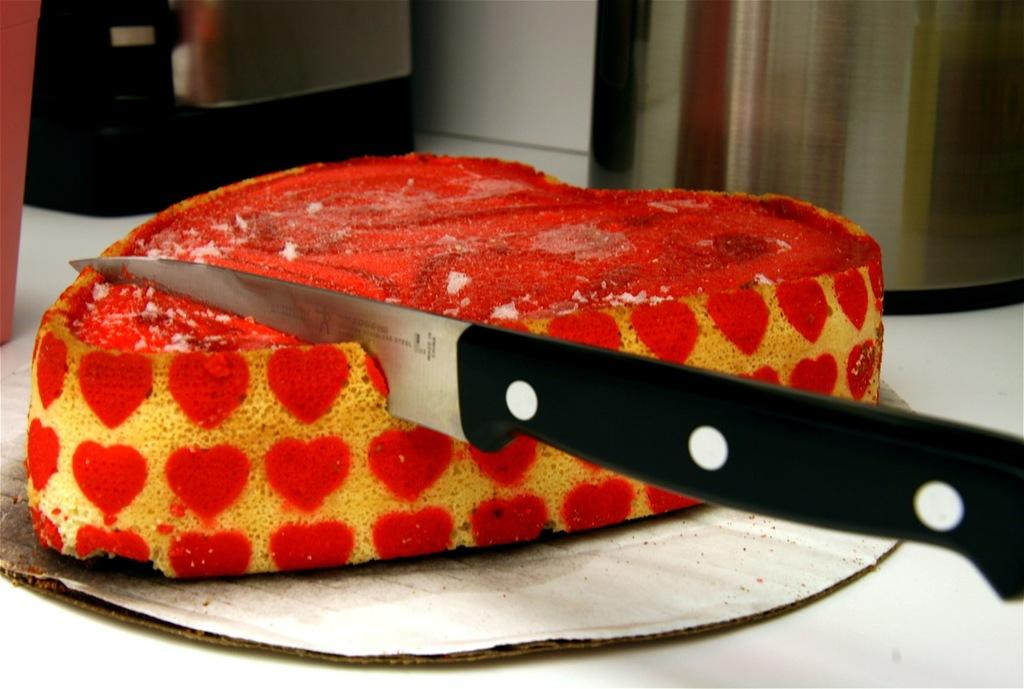What is the main food item in the image? There is a piece of cake in the image. What object might be used to cut the cake? There is a knife in the image. What type of advice can be seen written on the cake in the image? There is no advice written on the cake in the image; it is a piece of cake without any text. 